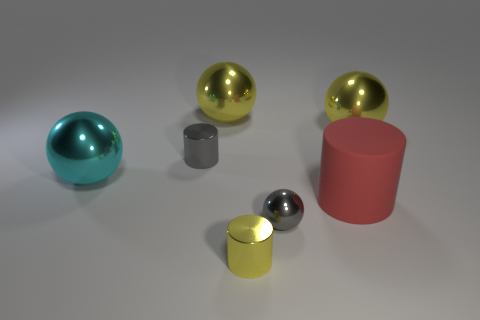Subtract all large matte cylinders. How many cylinders are left? 2 Add 2 big cyan rubber spheres. How many objects exist? 9 Subtract all gray cylinders. How many cylinders are left? 2 Subtract 2 cylinders. How many cylinders are left? 1 Subtract all gray cylinders. How many gray balls are left? 1 Subtract all large yellow objects. Subtract all big cyan shiny balls. How many objects are left? 4 Add 1 small gray things. How many small gray things are left? 3 Add 1 balls. How many balls exist? 5 Subtract 0 brown balls. How many objects are left? 7 Subtract all cylinders. How many objects are left? 4 